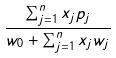<formula> <loc_0><loc_0><loc_500><loc_500>\frac { \sum _ { j = 1 } ^ { n } x _ { j } p _ { j } } { w _ { 0 } + \sum _ { j = 1 } ^ { n } x _ { j } w _ { j } }</formula> 